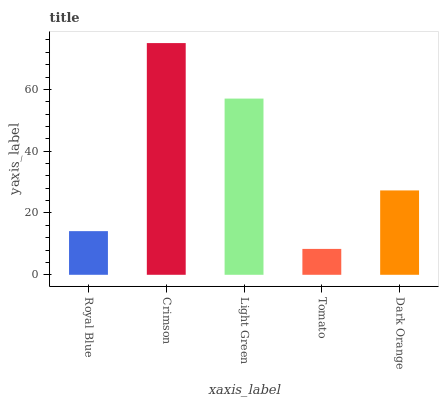Is Tomato the minimum?
Answer yes or no. Yes. Is Crimson the maximum?
Answer yes or no. Yes. Is Light Green the minimum?
Answer yes or no. No. Is Light Green the maximum?
Answer yes or no. No. Is Crimson greater than Light Green?
Answer yes or no. Yes. Is Light Green less than Crimson?
Answer yes or no. Yes. Is Light Green greater than Crimson?
Answer yes or no. No. Is Crimson less than Light Green?
Answer yes or no. No. Is Dark Orange the high median?
Answer yes or no. Yes. Is Dark Orange the low median?
Answer yes or no. Yes. Is Tomato the high median?
Answer yes or no. No. Is Crimson the low median?
Answer yes or no. No. 